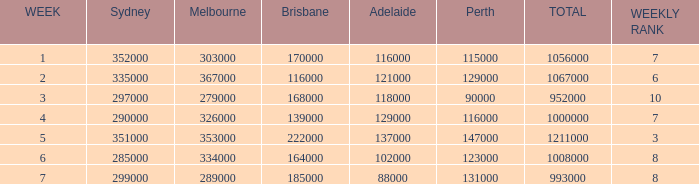What is the highest number of Brisbane viewers? 222000.0. 